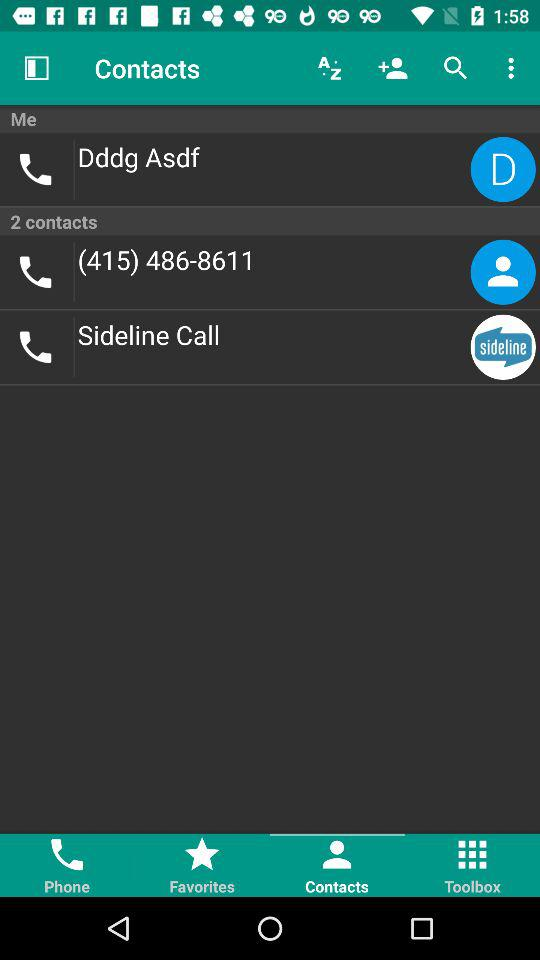What is the contact number of "Sideline Call"?
When the provided information is insufficient, respond with <no answer>. <no answer> 